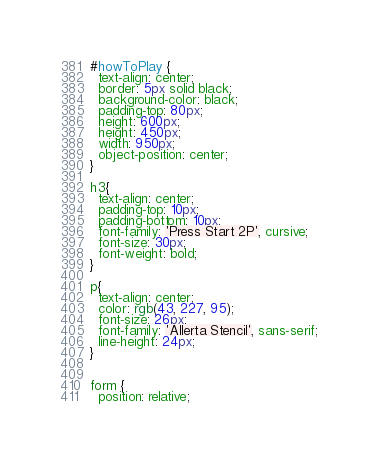Convert code to text. <code><loc_0><loc_0><loc_500><loc_500><_CSS_>#howToPlay {
  text-align: center;
  border: 5px solid black;
  background-color: black;
  padding-top: 80px;
  height: 600px;
  height: 450px;
  width: 950px;
  object-position: center;
}

h3{
  text-align: center;
  padding-top: 10px;
  padding-bottom: 10px;
  font-family: 'Press Start 2P', cursive;
  font-size: 30px;
  font-weight: bold;
}

p{
  text-align: center;
  color: rgb(43, 227, 95);
  font-size: 26px;
  font-family: 'Allerta Stencil', sans-serif;
  line-height: 24px;
}


form {
  position: relative;</code> 